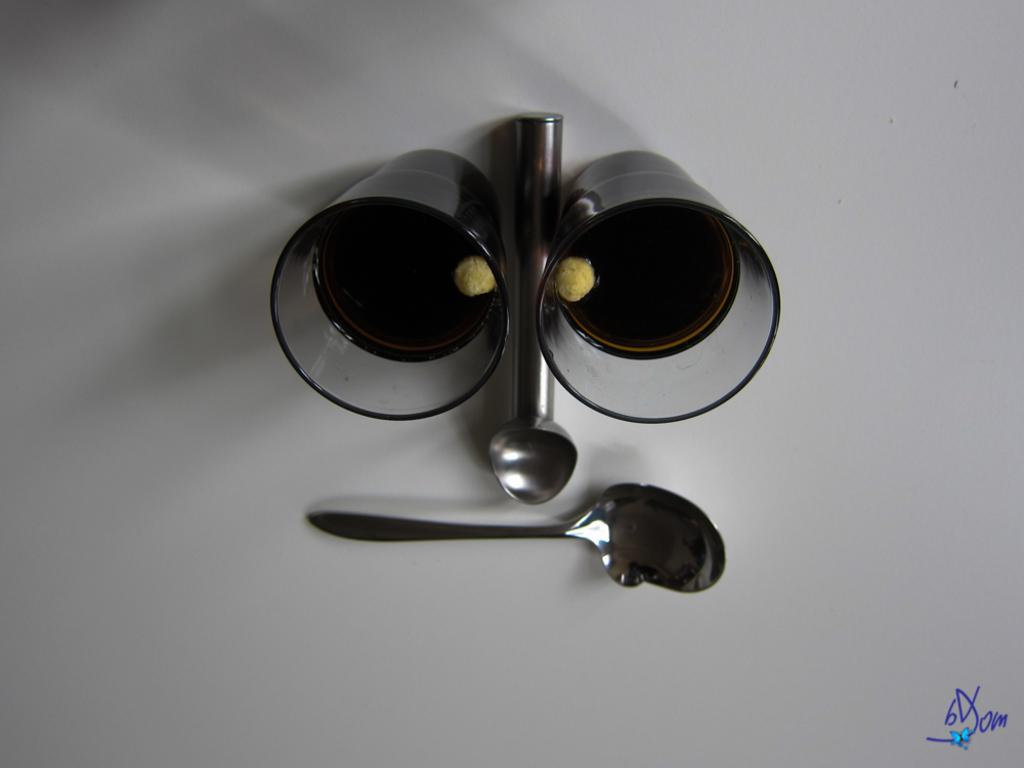What type of containers are present in the image? There are two glasses with a drink in the image. What utensils can be seen in the image? There are two spoons on a surface in the image. What type of river can be seen flowing through the image? There is no river present in the image. Can you tell me how much gold is in the glasses? There is no gold mentioned or visible in the image. 